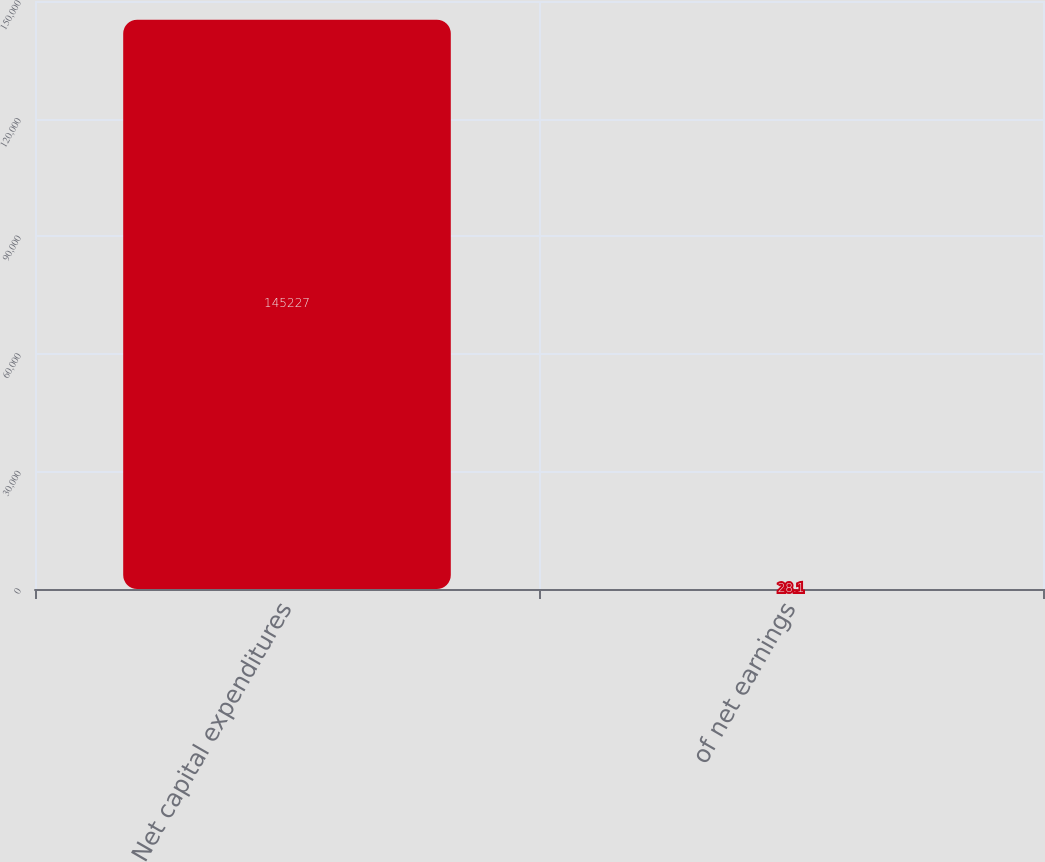Convert chart to OTSL. <chart><loc_0><loc_0><loc_500><loc_500><bar_chart><fcel>Net capital expenditures<fcel>of net earnings<nl><fcel>145227<fcel>28.1<nl></chart> 